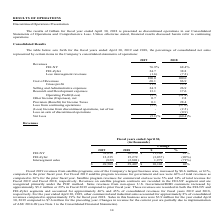From Frequency Electronics's financial document, What is the percentage of revenue from FEI-NY in 2018 and 2019 respectively? The document shows two values: 68.4% and 76.9%. From the document: "FEI-NY 76.9% 68.4% FEI-Zyfer 24.7 38.8 Less intersegment revenues (1.6) (7.2) 100.0 100.0 FEI-NY 76.9% 68.4% FEI-Zyfer 24.7 38.8 Less intersegment rev..." Also, What is the percentage of revenue from FEI-Zyfer in 2018 and 2019 respectively? The document shows two values: 38.8 and 24.7. From the document: "FEI-NY 76.9% 68.4% FEI-Zyfer 24.7 38.8 Less intersegment revenues (1.6) (7.2) 100.0 100.0 FEI-NY 76.9% 68.4% FEI-Zyfer 24.7 38.8 Less intersegment rev..." Also, What does the table show? for the fiscal years ended April 30, 2019 and 2018, the percentage of consolidated net sales represented by certain items in the Company’s consolidated statements of operations. The document states: ". Consolidated Results The table below sets forth for the fiscal years ended April 30, 2019 and 2018, the percentage of consolidated net sales represe..." Also, can you calculate: What is the difference in percentage of revenues from FEI-NY between 2019 and 2018? Based on the calculation: 76.9-68.4, the result is 8.5 (percentage). This is based on the information: "FEI-NY 76.9% 68.4% FEI-Zyfer 24.7 38.8 Less intersegment revenues (1.6) (7.2) 100.0 100.0 FEI-NY 76.9% 68.4% FEI-Zyfer 24.7 38.8 Less intersegment revenues (1.6) (7.2) 100.0 100.0..." The key data points involved are: 68.4, 76.9. Also, can you calculate: What is the average percentage of revenues from FEI-Zyfer in 2018 and 2019? To answer this question, I need to perform calculations using the financial data. The calculation is: (24.7+38.8)/2, which equals 31.75 (percentage). This is based on the information: "FEI-NY 76.9% 68.4% FEI-Zyfer 24.7 38.8 Less intersegment revenues (1.6) (7.2) 100.0 100.0 FEI-NY 76.9% 68.4% FEI-Zyfer 24.7 38.8 Less intersegment revenues (1.6) (7.2) 100.0 100.0..." The key data points involved are: 24.7, 38.8. Also, can you calculate: What is the average selling and administrative expenses in 2018 and 2019? To answer this question, I need to perform calculations using the financial data. The calculation is: (24.5+26.9)/2, which equals 25.7 (percentage). This is based on the information: "Selling and Administrative expenses 24.5 26.9 Research and Development expenses 13.1 17.6 Operating Profit/(Loss) (5.7) (31.4) Selling and Administrative expenses 24.5 26.9 Research and Development ex..." The key data points involved are: 24.5, 26.9. 